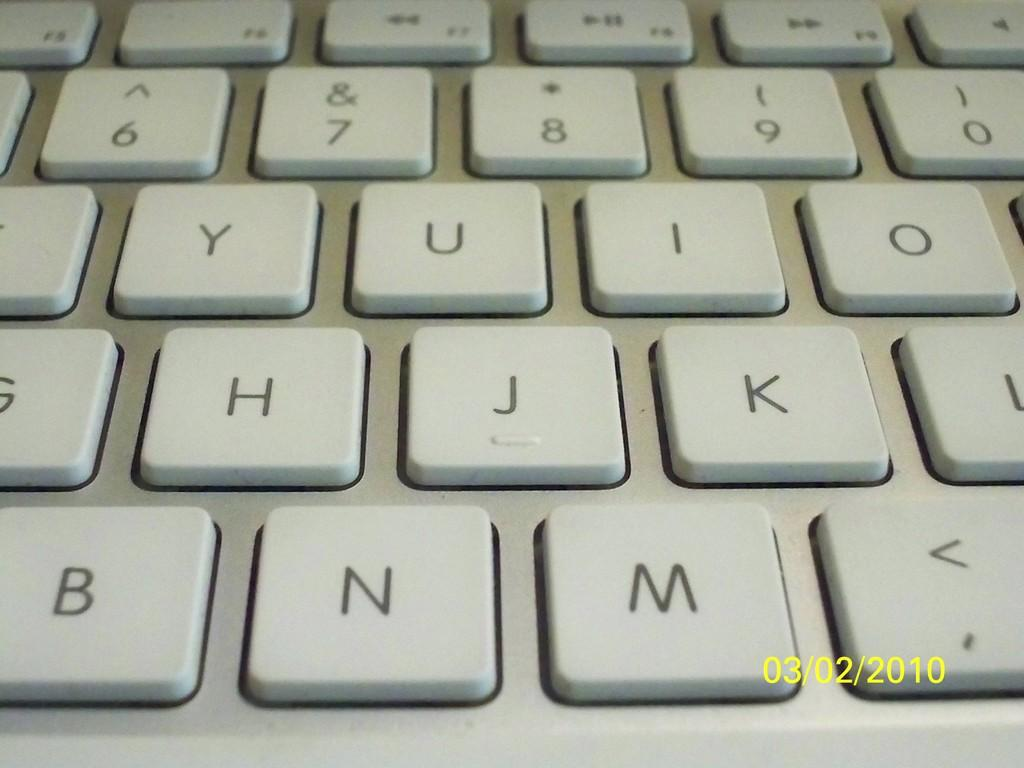<image>
Describe the image concisely. White keyboard that has the N key between the B and M key. 